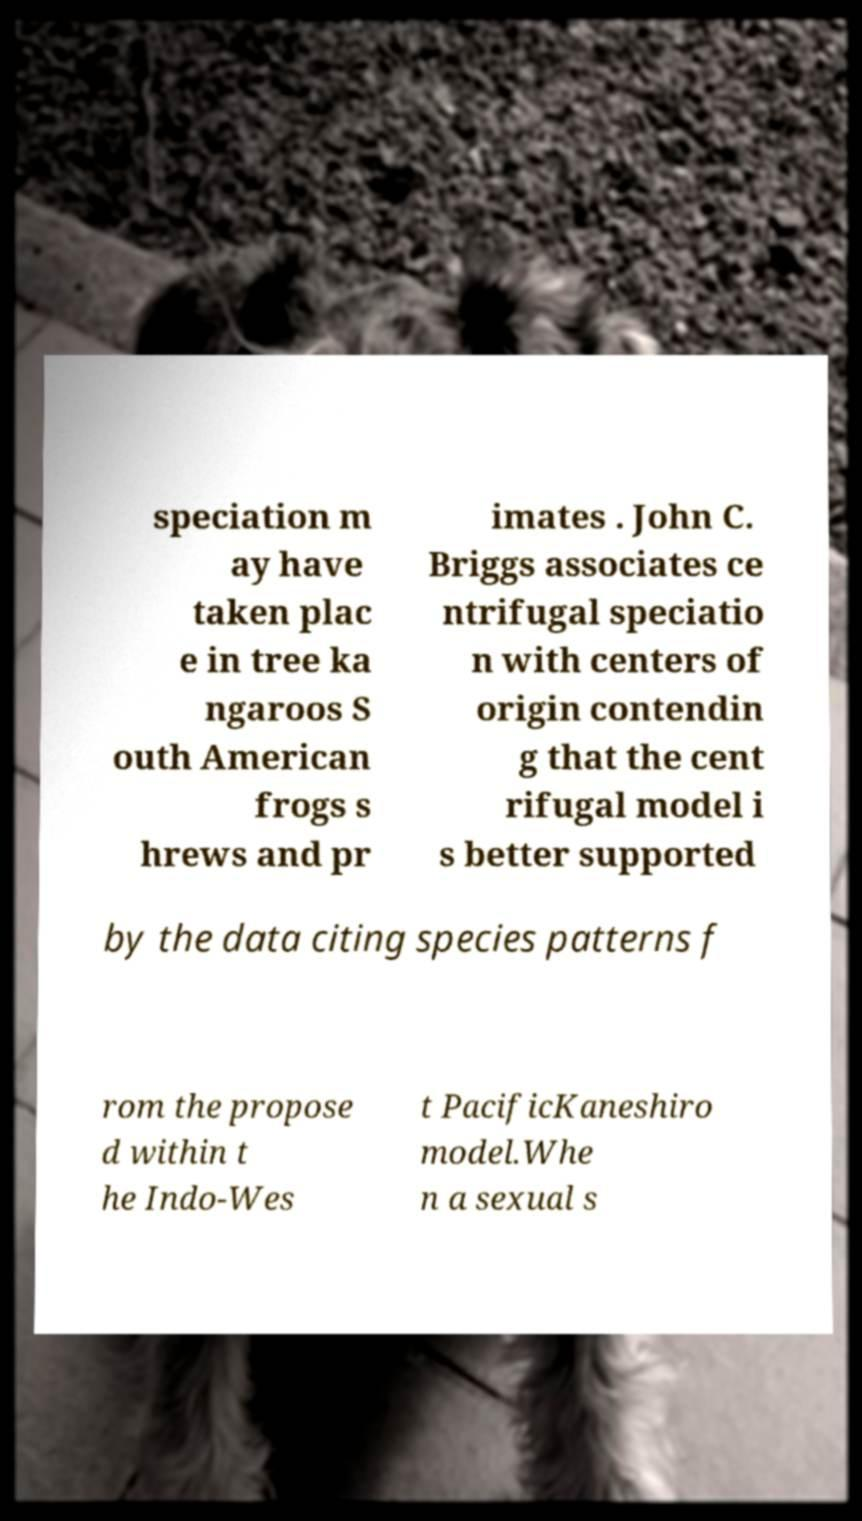What messages or text are displayed in this image? I need them in a readable, typed format. speciation m ay have taken plac e in tree ka ngaroos S outh American frogs s hrews and pr imates . John C. Briggs associates ce ntrifugal speciatio n with centers of origin contendin g that the cent rifugal model i s better supported by the data citing species patterns f rom the propose d within t he Indo-Wes t PacificKaneshiro model.Whe n a sexual s 